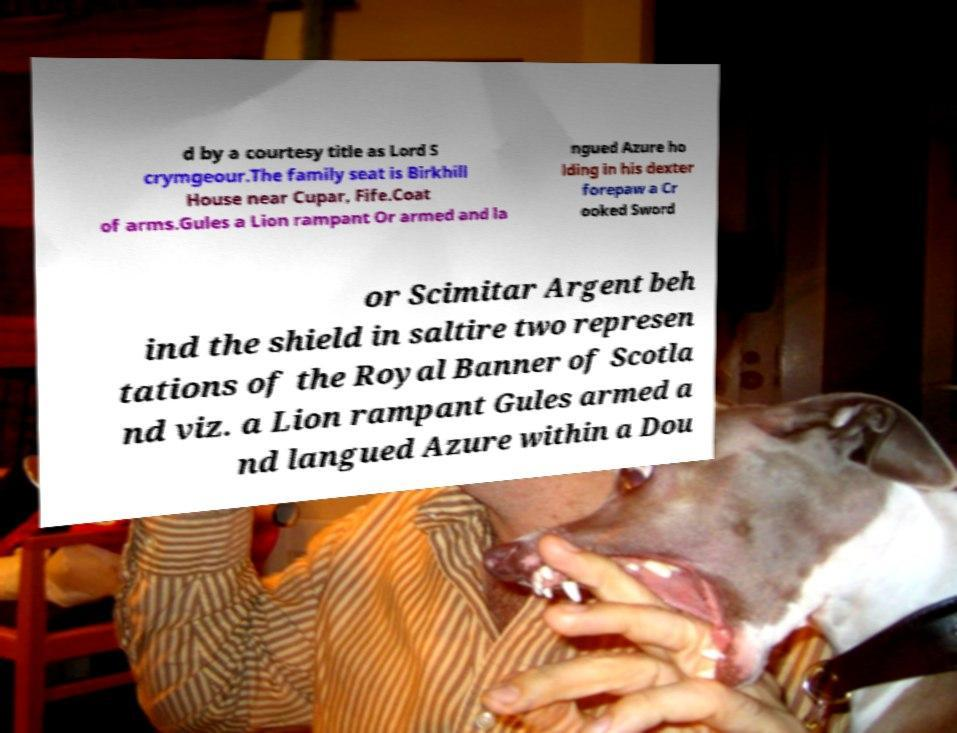Could you extract and type out the text from this image? d by a courtesy title as Lord S crymgeour.The family seat is Birkhill House near Cupar, Fife.Coat of arms.Gules a Lion rampant Or armed and la ngued Azure ho lding in his dexter forepaw a Cr ooked Sword or Scimitar Argent beh ind the shield in saltire two represen tations of the Royal Banner of Scotla nd viz. a Lion rampant Gules armed a nd langued Azure within a Dou 